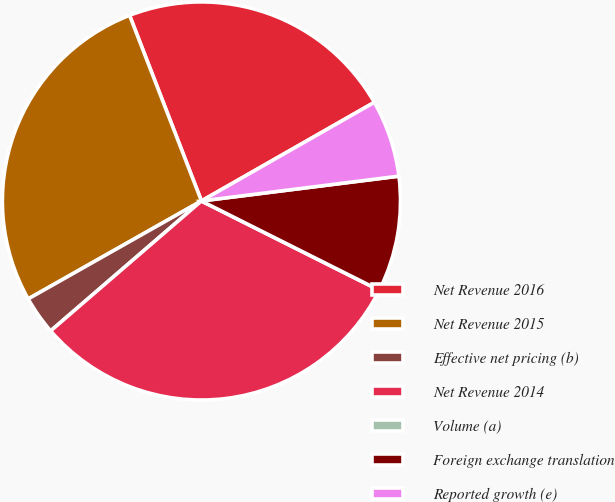Convert chart to OTSL. <chart><loc_0><loc_0><loc_500><loc_500><pie_chart><fcel>Net Revenue 2016<fcel>Net Revenue 2015<fcel>Effective net pricing (b)<fcel>Net Revenue 2014<fcel>Volume (a)<fcel>Foreign exchange translation<fcel>Reported growth (e)<nl><fcel>22.63%<fcel>27.31%<fcel>3.13%<fcel>31.28%<fcel>0.0%<fcel>9.39%<fcel>6.26%<nl></chart> 